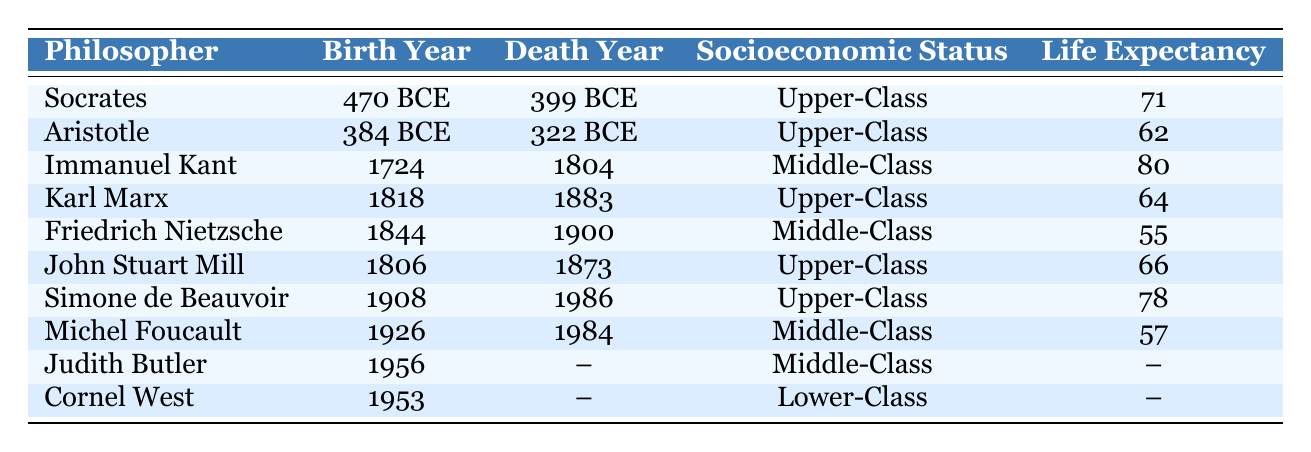What is the life expectancy of Socrates? Socrates' life expectancy is directly listed in the table under the corresponding column, which shows 71 years.
Answer: 71 What socioeconomic status did Aristotle belong to? By looking at the row for Aristotle, it is clear that his socioeconomic status is recorded as Upper-Class.
Answer: Upper-Class Which philosopher had the highest life expectancy and what was it? Immanuel Kant has the highest life expectancy among the philosophers listed, which is noted as 80 years in the table.
Answer: 80 Is there a philosopher recorded with a life expectancy of 55 years? Yes, the table shows that Friedrich Nietzsche had a life expectancy of 55 years, confirming that such a philosopher exists in the data.
Answer: Yes What is the average life expectancy of philosophers in the Upper-Class category? The philosophers in the Upper-Class category are Socrates (71), Aristotle (62), Karl Marx (64), John Stuart Mill (66), and Simone de Beauvoir (78). Summing these values gives 71 + 62 + 64 + 66 + 78 = 341. There are five philosophers in this group, so the average is 341 / 5 = 68.2.
Answer: 68.2 How many philosophers listed have a Middle-Class socioeconomic status? By counting the entries in the Middle-Class category, we see Immanuel Kant, Friedrich Nietzsche, Michel Foucault, and Judith Butler listed, which provides a total count of four philosophers.
Answer: 4 Which socioeconomic status corresponds to the lowest life expectancy recorded in the table? The lowest life expectancy is 55 years, which corresponds to Friedrich Nietzsche, who is categorized as Middle-Class. Hence, Middle-Class is associated with this life expectancy.
Answer: Middle-Class Are there any philosophers whose life expectancy is not listed? Yes, both Judith Butler and Cornel West have their life expectancy recorded as null, indicating that it is not available in the data provided.
Answer: Yes What is the difference in life expectancy between the oldest philosopher, Socrates, and the youngest recorded philosopher, Cornel West? Socrates lived to a life expectancy of 71 years, while Cornel West has an unspecified life expectancy. Since we cannot calculate a difference with an unknown value, we conclude that no numerical comparison can be made.
Answer: Cannot be determined 